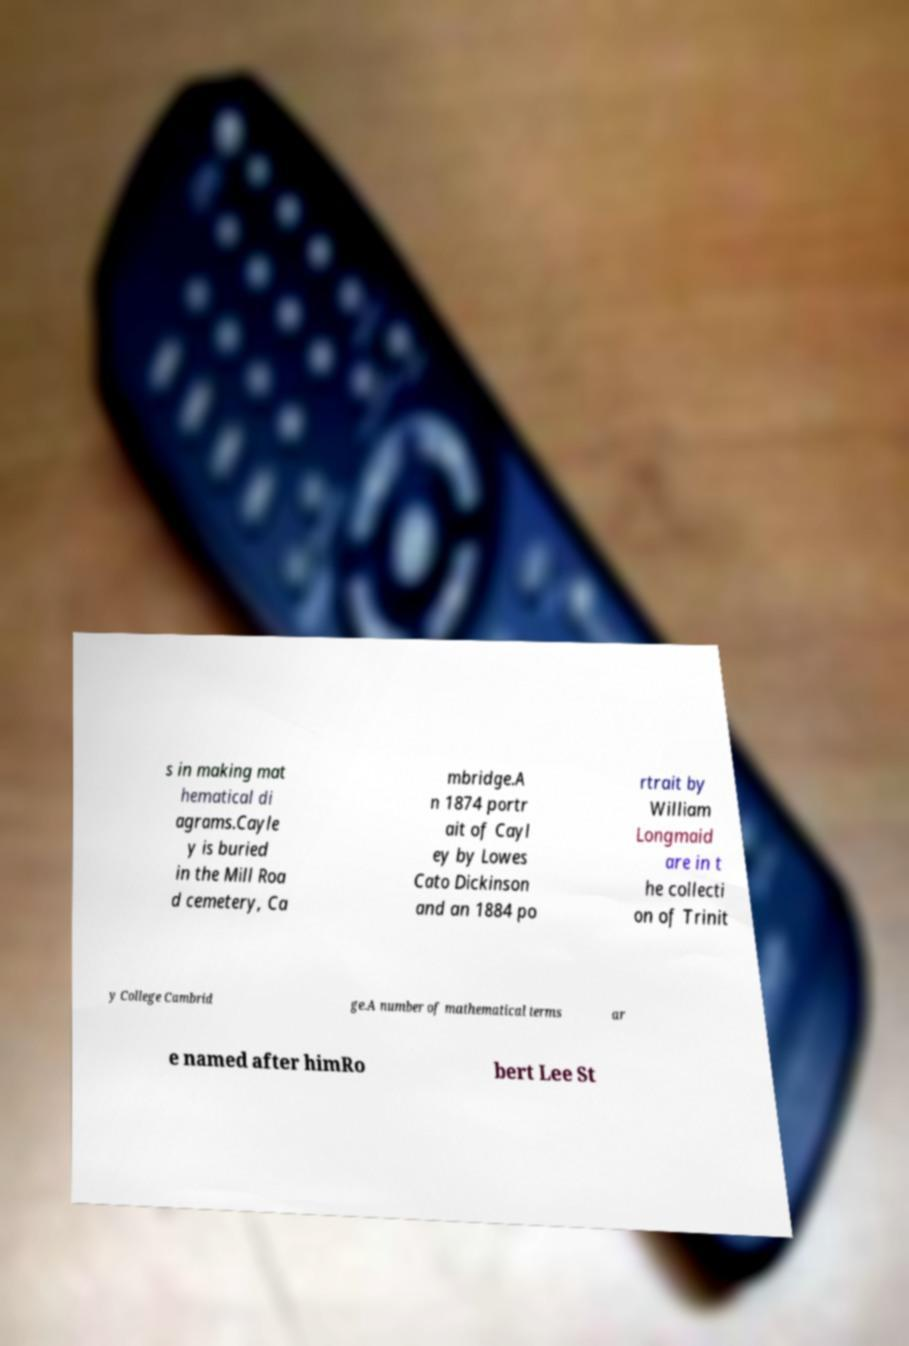Could you assist in decoding the text presented in this image and type it out clearly? s in making mat hematical di agrams.Cayle y is buried in the Mill Roa d cemetery, Ca mbridge.A n 1874 portr ait of Cayl ey by Lowes Cato Dickinson and an 1884 po rtrait by William Longmaid are in t he collecti on of Trinit y College Cambrid ge.A number of mathematical terms ar e named after himRo bert Lee St 